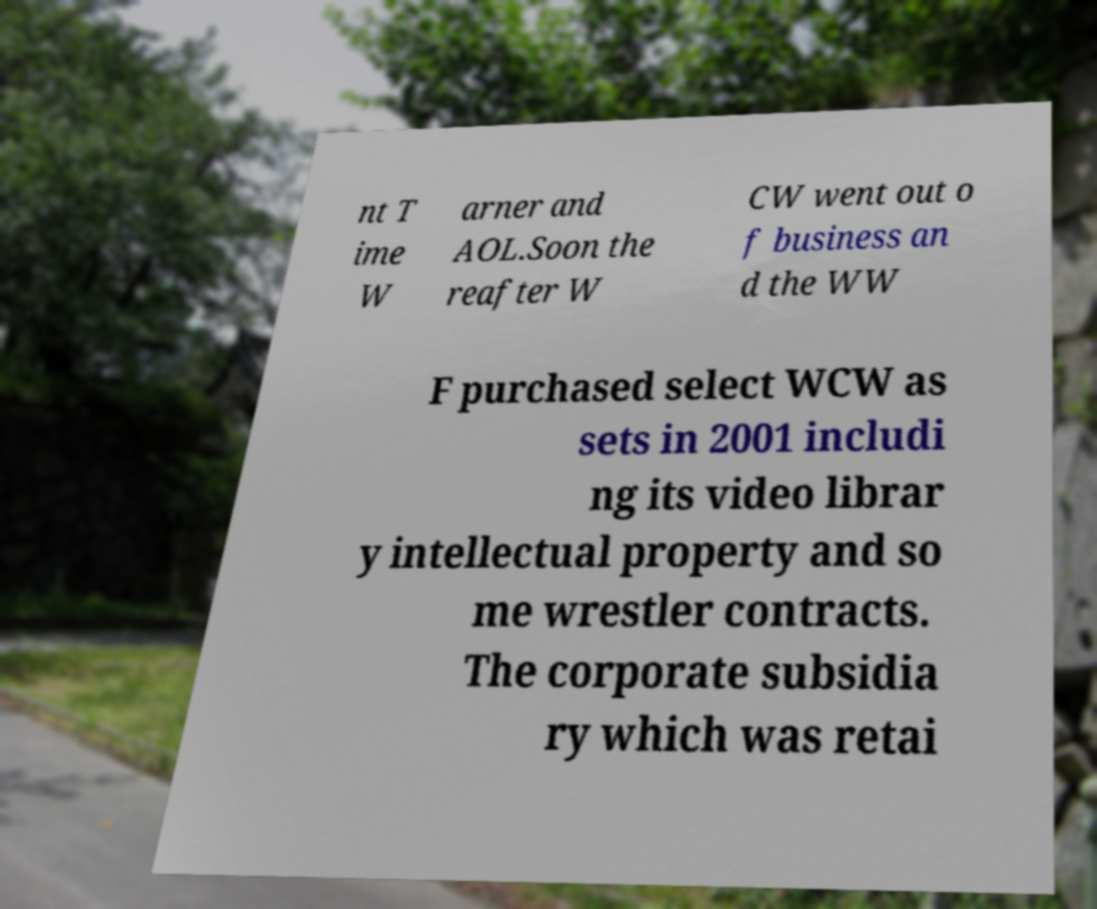I need the written content from this picture converted into text. Can you do that? nt T ime W arner and AOL.Soon the reafter W CW went out o f business an d the WW F purchased select WCW as sets in 2001 includi ng its video librar y intellectual property and so me wrestler contracts. The corporate subsidia ry which was retai 